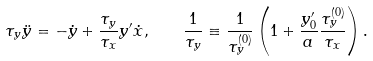Convert formula to latex. <formula><loc_0><loc_0><loc_500><loc_500>\tau _ { y } \ddot { y } = - \dot { y } + \frac { \tau _ { y } } { \tau _ { x } } y ^ { \prime } \dot { x } , \quad \frac { 1 } { \tau _ { y } } \equiv \frac { 1 } { \tau ^ { ( 0 ) } _ { y } } \left ( 1 + \frac { y ^ { \prime } _ { 0 } } { a } \frac { \tau ^ { ( 0 ) } _ { y } } { \tau _ { x } } \right ) .</formula> 